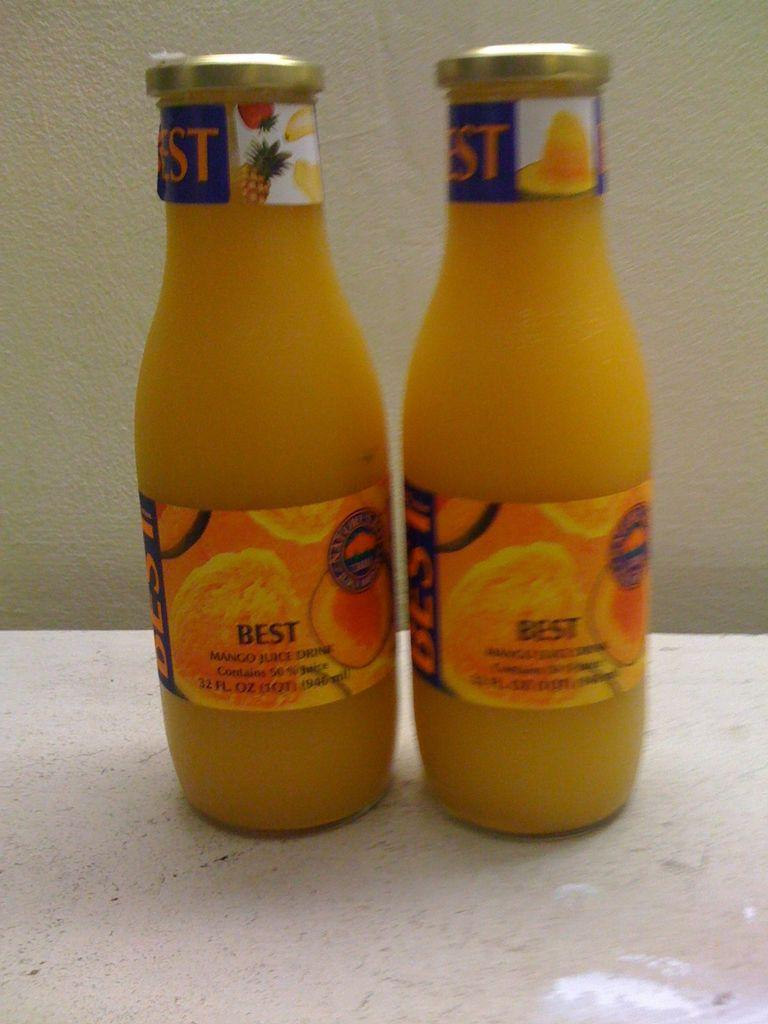Provide a one-sentence caption for the provided image. Two glass bottles of a fruit juice called Best. 